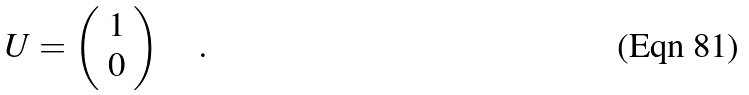Convert formula to latex. <formula><loc_0><loc_0><loc_500><loc_500>U = \left ( \begin{array} { c } { 1 } \\ { 0 } \end{array} \right ) \quad .</formula> 